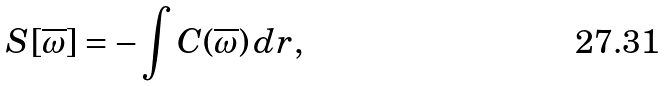<formula> <loc_0><loc_0><loc_500><loc_500>S [ \overline { \omega } ] = - \int C ( \overline { \omega } ) \, d { r } ,</formula> 